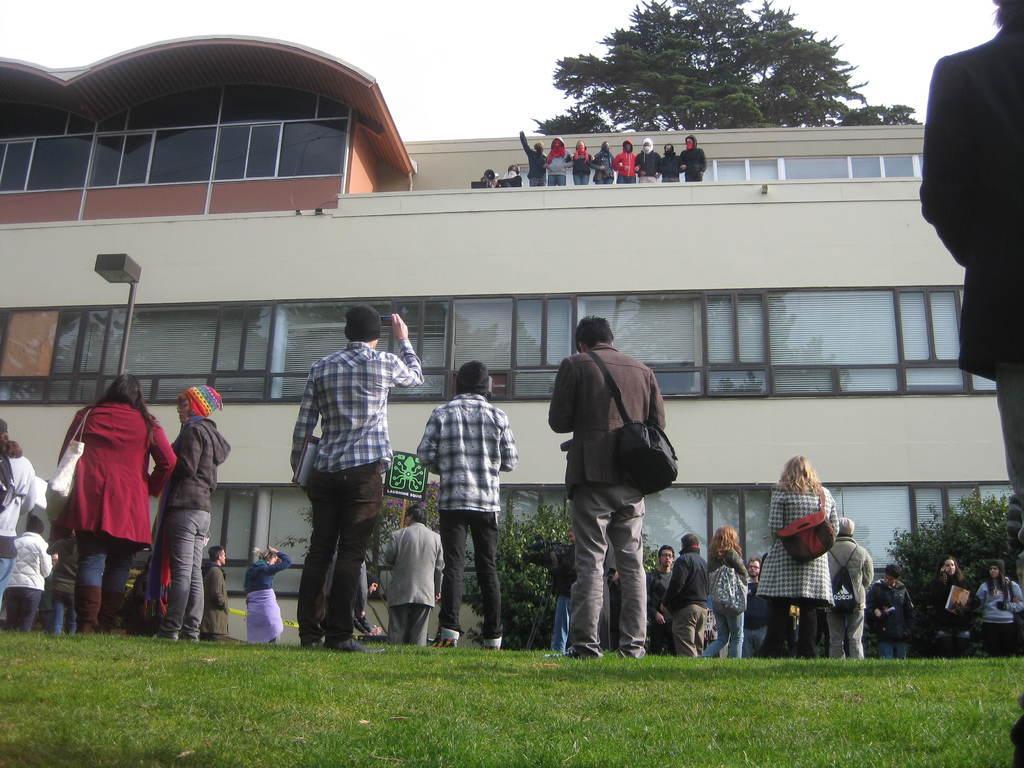Can you describe this image briefly? In this i mage I can see a building , in front of building I can see a pole and some persons and planets visible, at the top of building I can see persons and I can see persons visible at the top I can see the sky and tree. 